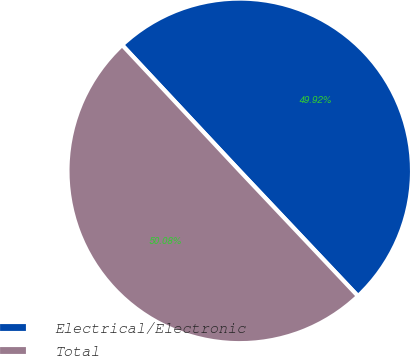Convert chart to OTSL. <chart><loc_0><loc_0><loc_500><loc_500><pie_chart><fcel>Electrical/Electronic<fcel>Total<nl><fcel>49.92%<fcel>50.08%<nl></chart> 